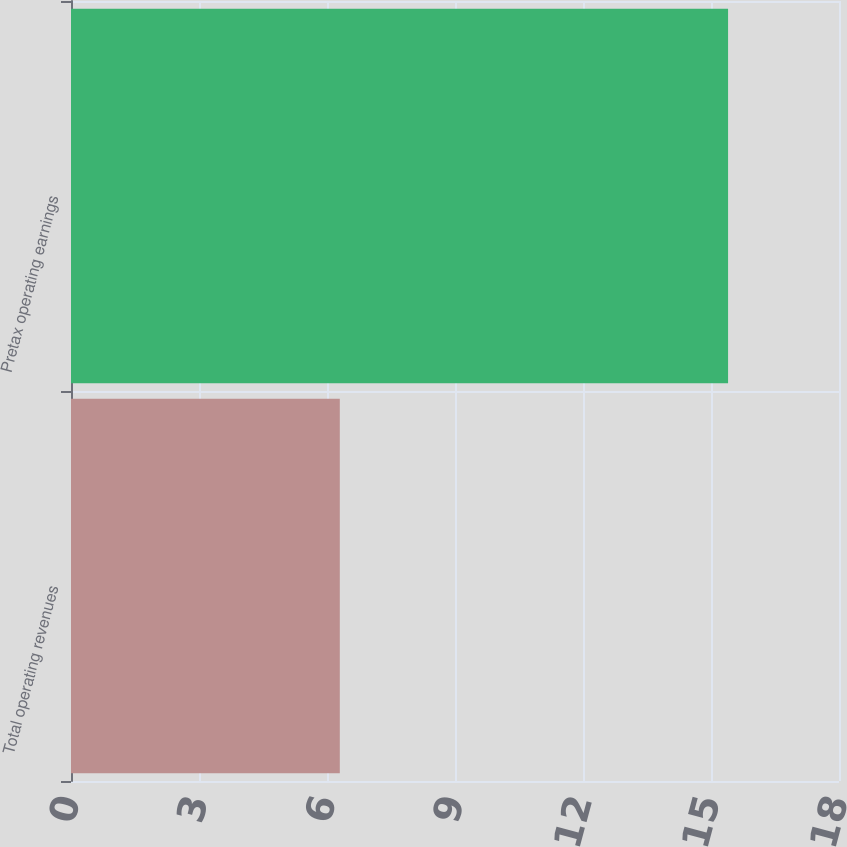<chart> <loc_0><loc_0><loc_500><loc_500><bar_chart><fcel>Total operating revenues<fcel>Pretax operating earnings<nl><fcel>6.3<fcel>15.4<nl></chart> 